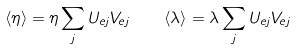<formula> <loc_0><loc_0><loc_500><loc_500>\langle \eta \rangle = \eta \sum _ { j } U _ { e j } V _ { e j } \quad \langle \lambda \rangle = \lambda \sum _ { j } U _ { e j } V _ { e j }</formula> 